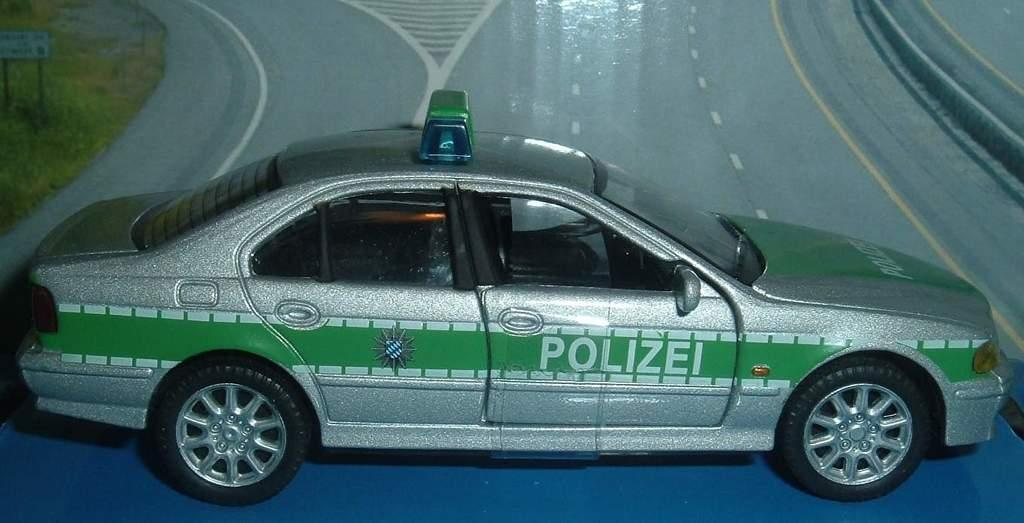What is the main subject in the foreground of the image? There is a toy car in the foreground of the image. What is the toy car placed on? The toy car is on a blue surface. What can be seen in the background of the image? There is a painting of a road and grass visible in the background of the image. What other object is present in the background of the image? There is a board in the background of the image. How many cherries are on the toy car in the image? There are no cherries present on the toy car or in the image. What type of division is being taught in the room in the image? There is no room or indication of any teaching activity in the image. 